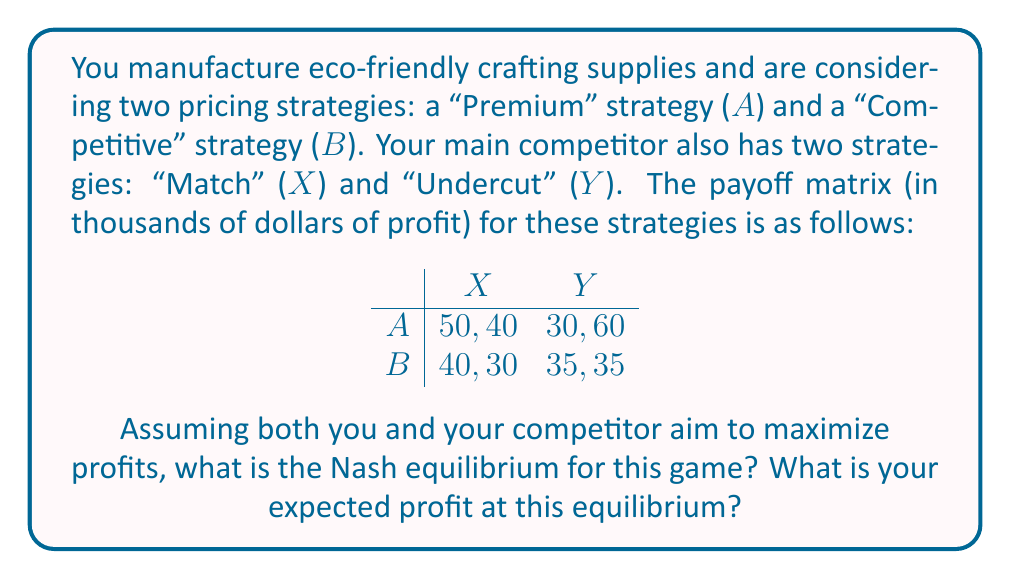What is the answer to this math problem? To solve this problem, we need to find the Nash equilibrium using the following steps:

1. Identify dominant strategies:
   For you (row player):
   - If competitor chooses X: $50 > 40$, so A is better
   - If competitor chooses Y: $30 < 35$, so B is better
   No dominant strategy for you.

   For competitor (column player):
   - If you choose A: $40 < 60$, so Y is better
   - If you choose B: $30 < 35$, so Y is better
   Y is a dominant strategy for the competitor.

2. Since there's a dominant strategy for the competitor, we can eliminate column X.

3. Given that the competitor will always choose Y, your best response is to choose B (35 > 30).

4. Therefore, the Nash equilibrium is (B, Y).

At this equilibrium:
- You choose the "Competitive" strategy (B)
- Your competitor chooses the "Undercut" strategy (Y)
- Your profit is $35,000

This equilibrium represents a situation where both you and your competitor are pricing competitively, which aligns with maintaining eco-friendly practices by making sustainable products more accessible to consumers through competitive pricing.
Answer: The Nash equilibrium is (B, Y), and your expected profit at this equilibrium is $35,000. 